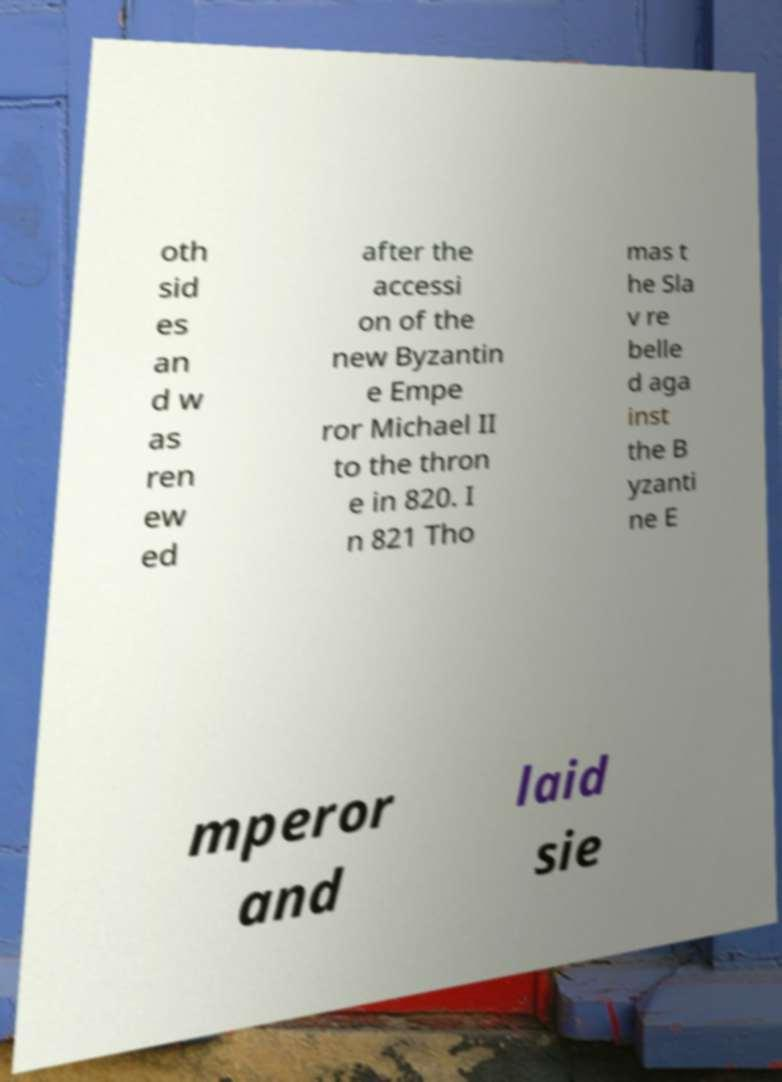I need the written content from this picture converted into text. Can you do that? oth sid es an d w as ren ew ed after the accessi on of the new Byzantin e Empe ror Michael II to the thron e in 820. I n 821 Tho mas t he Sla v re belle d aga inst the B yzanti ne E mperor and laid sie 